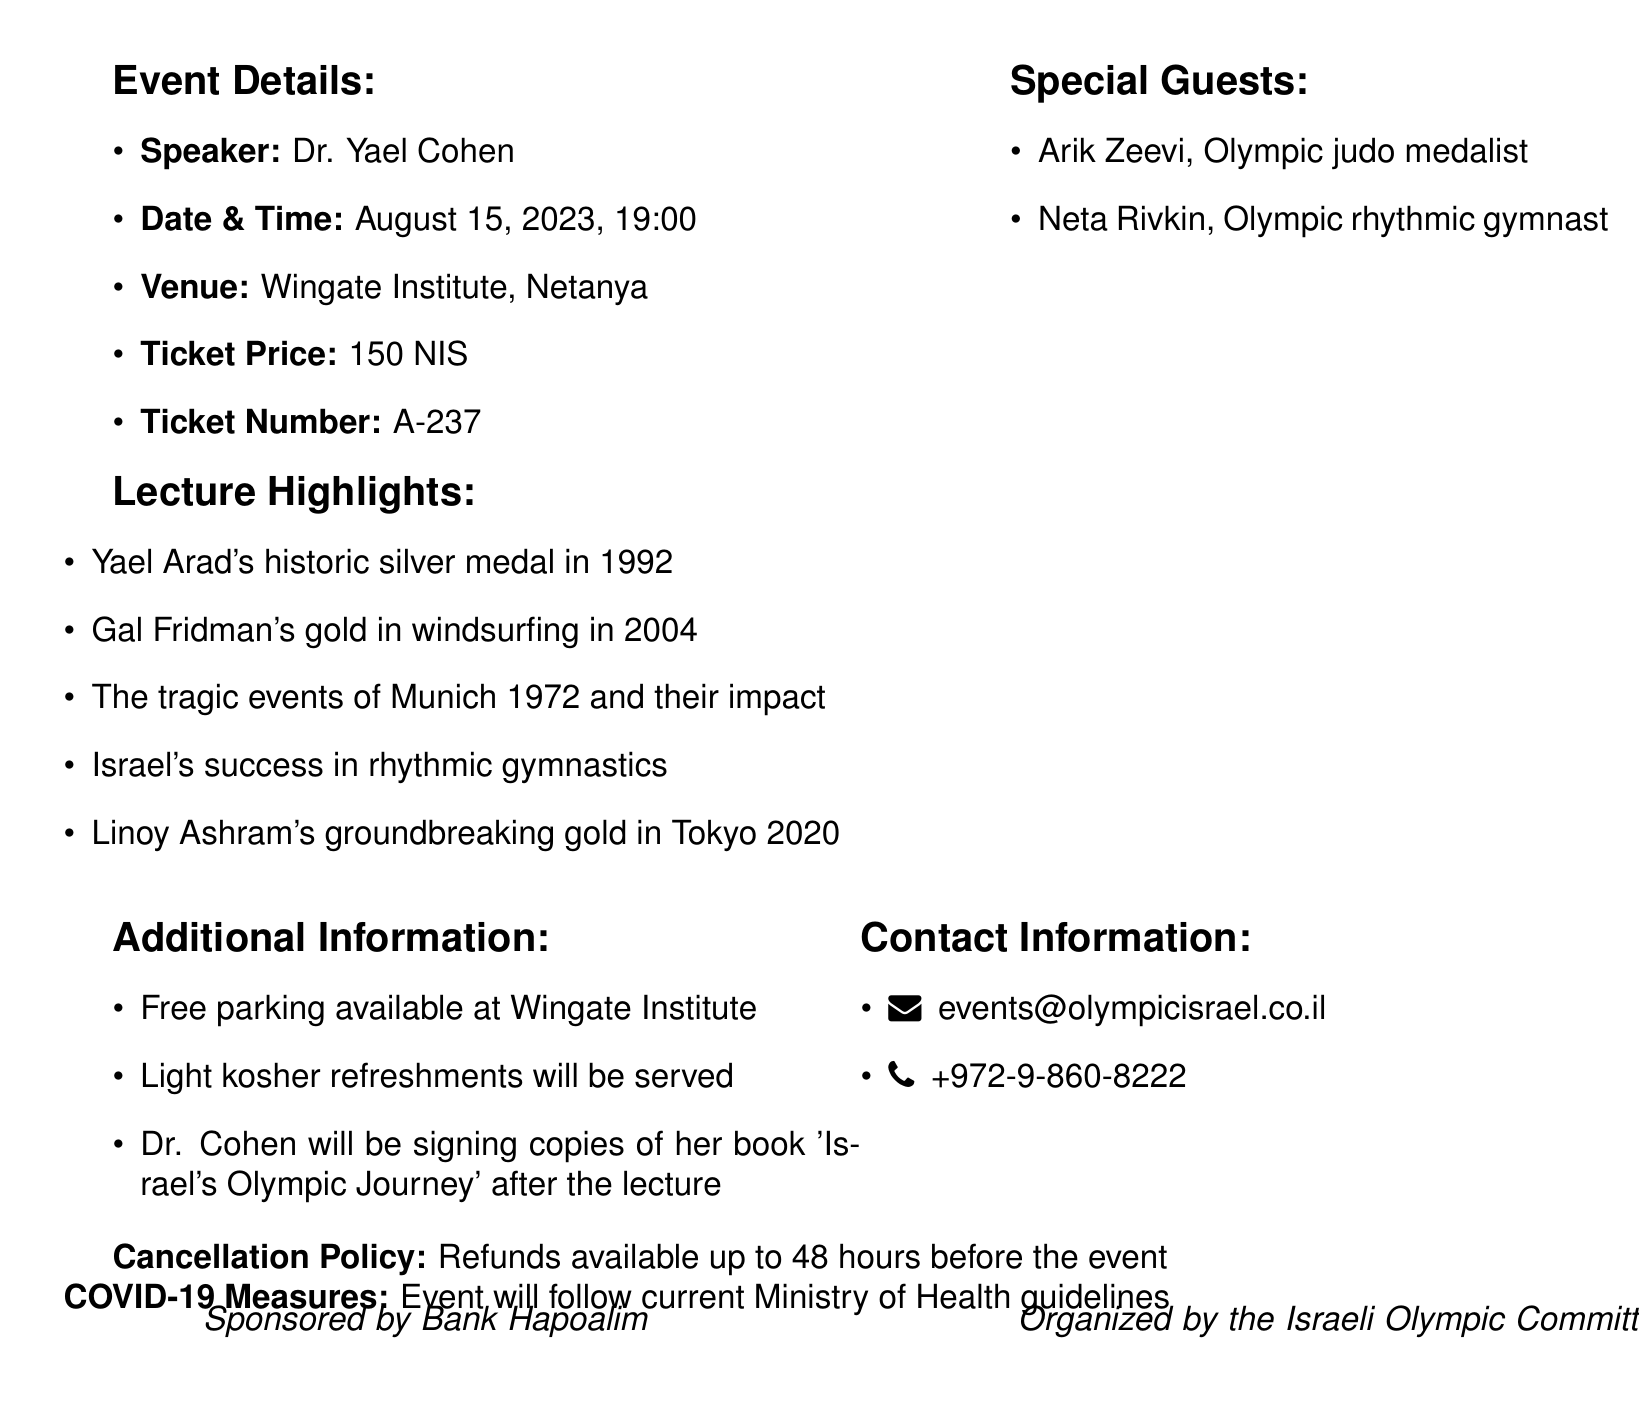What is the name of the event? The name of the event is provided at the top of the document, showcasing its focus on Israeli Olympians.
Answer: Exclusive Lecture: The Golden Legacy of Israeli Olympians Who is the speaker? The document lists the speaker in the event details section, highlighting their expertise in Olympic history.
Answer: Dr. Yael Cohen When is the event scheduled? The document specifies the date and time, crucial for attendees to plan their visit.
Answer: August 15, 2023 What is the ticket price? The price of attending the event is detailed, which is important for budgeting purposes.
Answer: 150 NIS Which Olympic achievement is highlighted from the 2004 Olympics? The document mentions specific achievements under lecture highlights, showcasing significant moments in Israeli Olympic history.
Answer: Gal Fridman's gold in windsurfing Who are the special guests? The document lists notable figures in the Olympic community attending the event, enhancing its significance.
Answer: Arik Zeevi, Neta Rivkin What type of refreshments will be served? The additional information section specifies the nature of refreshments available to attendees.
Answer: Light kosher refreshments What is the cancellation policy? The document includes crucial information regarding event refunds, important for attendee planning.
Answer: Refunds available up to 48 hours before the event What COVID-19 measures are being followed? The document mentions health guidelines, providing reassurance for attendees about safety during the event.
Answer: Current Ministry of Health guidelines 